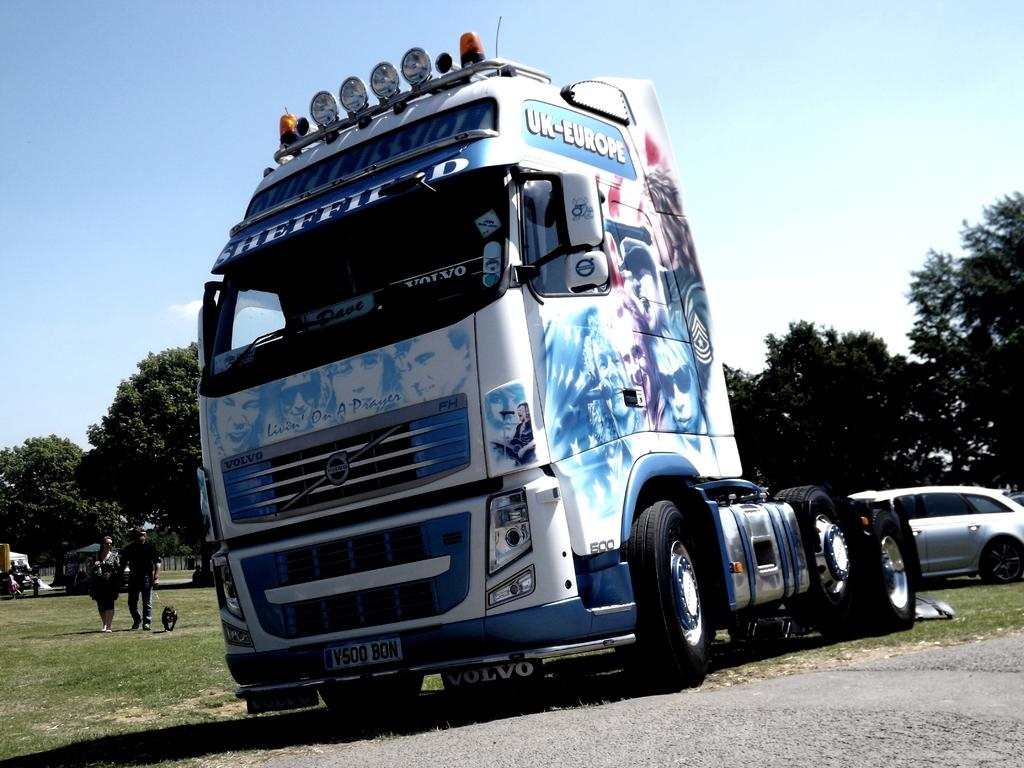What types of objects are present in the image? There are vehicles, trees, and people in the image. Can you describe the natural elements in the image? There are trees in the image. What is the color of the sky in the image? The sky is blue and white in color. How many oranges are hanging from the trees in the image? There are no oranges present in the image; it features vehicles, trees, and people. Is there a guitar being played by someone in the image? There is no guitar present in the image. 